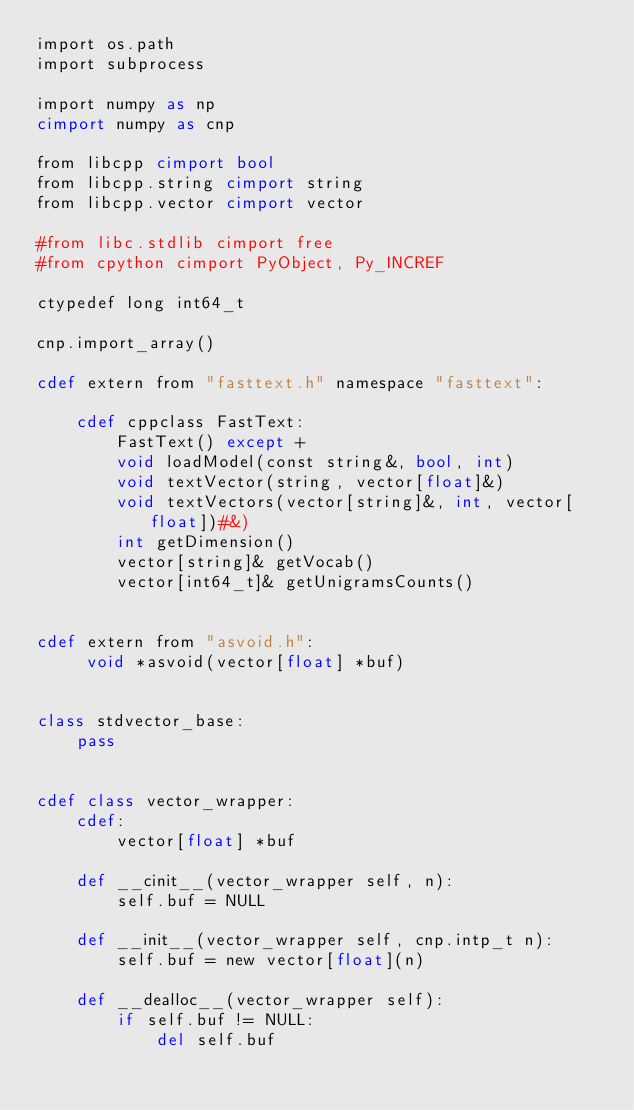Convert code to text. <code><loc_0><loc_0><loc_500><loc_500><_Cython_>import os.path
import subprocess

import numpy as np
cimport numpy as cnp

from libcpp cimport bool
from libcpp.string cimport string
from libcpp.vector cimport vector

#from libc.stdlib cimport free
#from cpython cimport PyObject, Py_INCREF

ctypedef long int64_t

cnp.import_array()

cdef extern from "fasttext.h" namespace "fasttext":

    cdef cppclass FastText:
        FastText() except +
        void loadModel(const string&, bool, int)
        void textVector(string, vector[float]&)
        void textVectors(vector[string]&, int, vector[float])#&)
        int getDimension()
        vector[string]& getVocab()
        vector[int64_t]& getUnigramsCounts()


cdef extern from "asvoid.h":
     void *asvoid(vector[float] *buf)


class stdvector_base:
    pass


cdef class vector_wrapper:
    cdef:
        vector[float] *buf

    def __cinit__(vector_wrapper self, n):
        self.buf = NULL

    def __init__(vector_wrapper self, cnp.intp_t n):
        self.buf = new vector[float](n)

    def __dealloc__(vector_wrapper self):
        if self.buf != NULL:
            del self.buf
</code> 